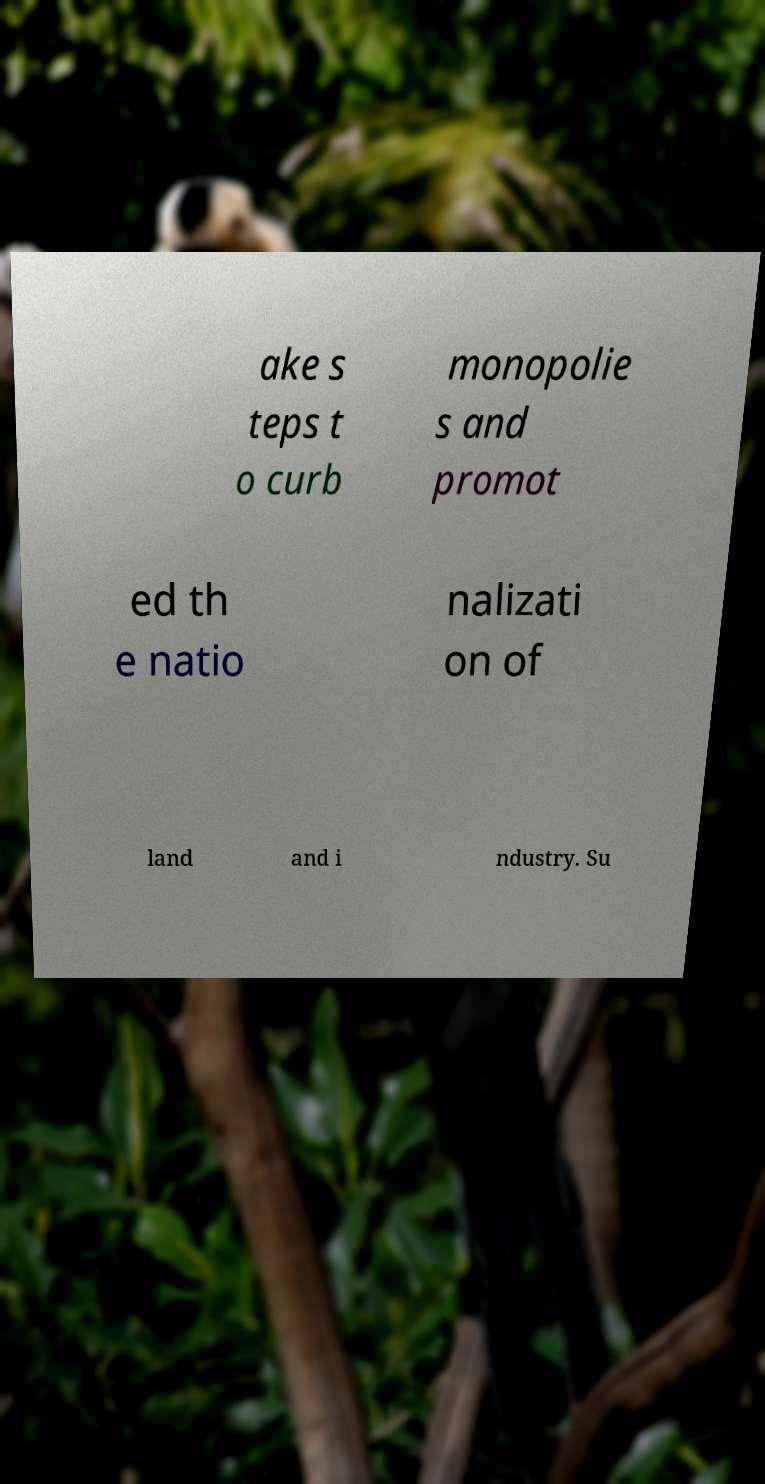Please identify and transcribe the text found in this image. ake s teps t o curb monopolie s and promot ed th e natio nalizati on of land and i ndustry. Su 